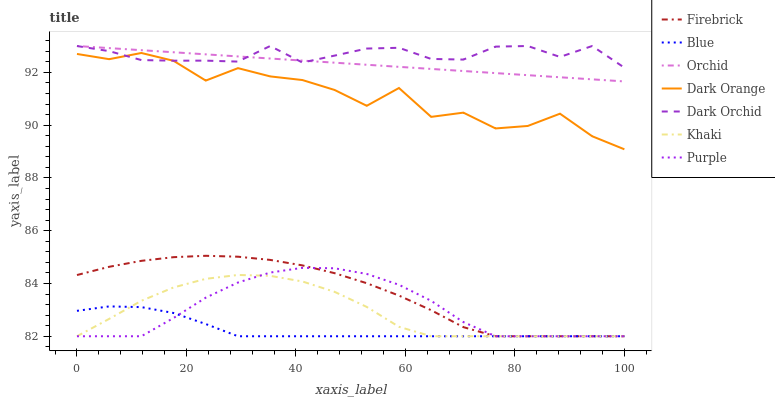Does Blue have the minimum area under the curve?
Answer yes or no. Yes. Does Dark Orchid have the maximum area under the curve?
Answer yes or no. Yes. Does Dark Orange have the minimum area under the curve?
Answer yes or no. No. Does Dark Orange have the maximum area under the curve?
Answer yes or no. No. Is Orchid the smoothest?
Answer yes or no. Yes. Is Dark Orange the roughest?
Answer yes or no. Yes. Is Khaki the smoothest?
Answer yes or no. No. Is Khaki the roughest?
Answer yes or no. No. Does Blue have the lowest value?
Answer yes or no. Yes. Does Dark Orange have the lowest value?
Answer yes or no. No. Does Orchid have the highest value?
Answer yes or no. Yes. Does Dark Orange have the highest value?
Answer yes or no. No. Is Blue less than Dark Orchid?
Answer yes or no. Yes. Is Orchid greater than Purple?
Answer yes or no. Yes. Does Firebrick intersect Khaki?
Answer yes or no. Yes. Is Firebrick less than Khaki?
Answer yes or no. No. Is Firebrick greater than Khaki?
Answer yes or no. No. Does Blue intersect Dark Orchid?
Answer yes or no. No. 